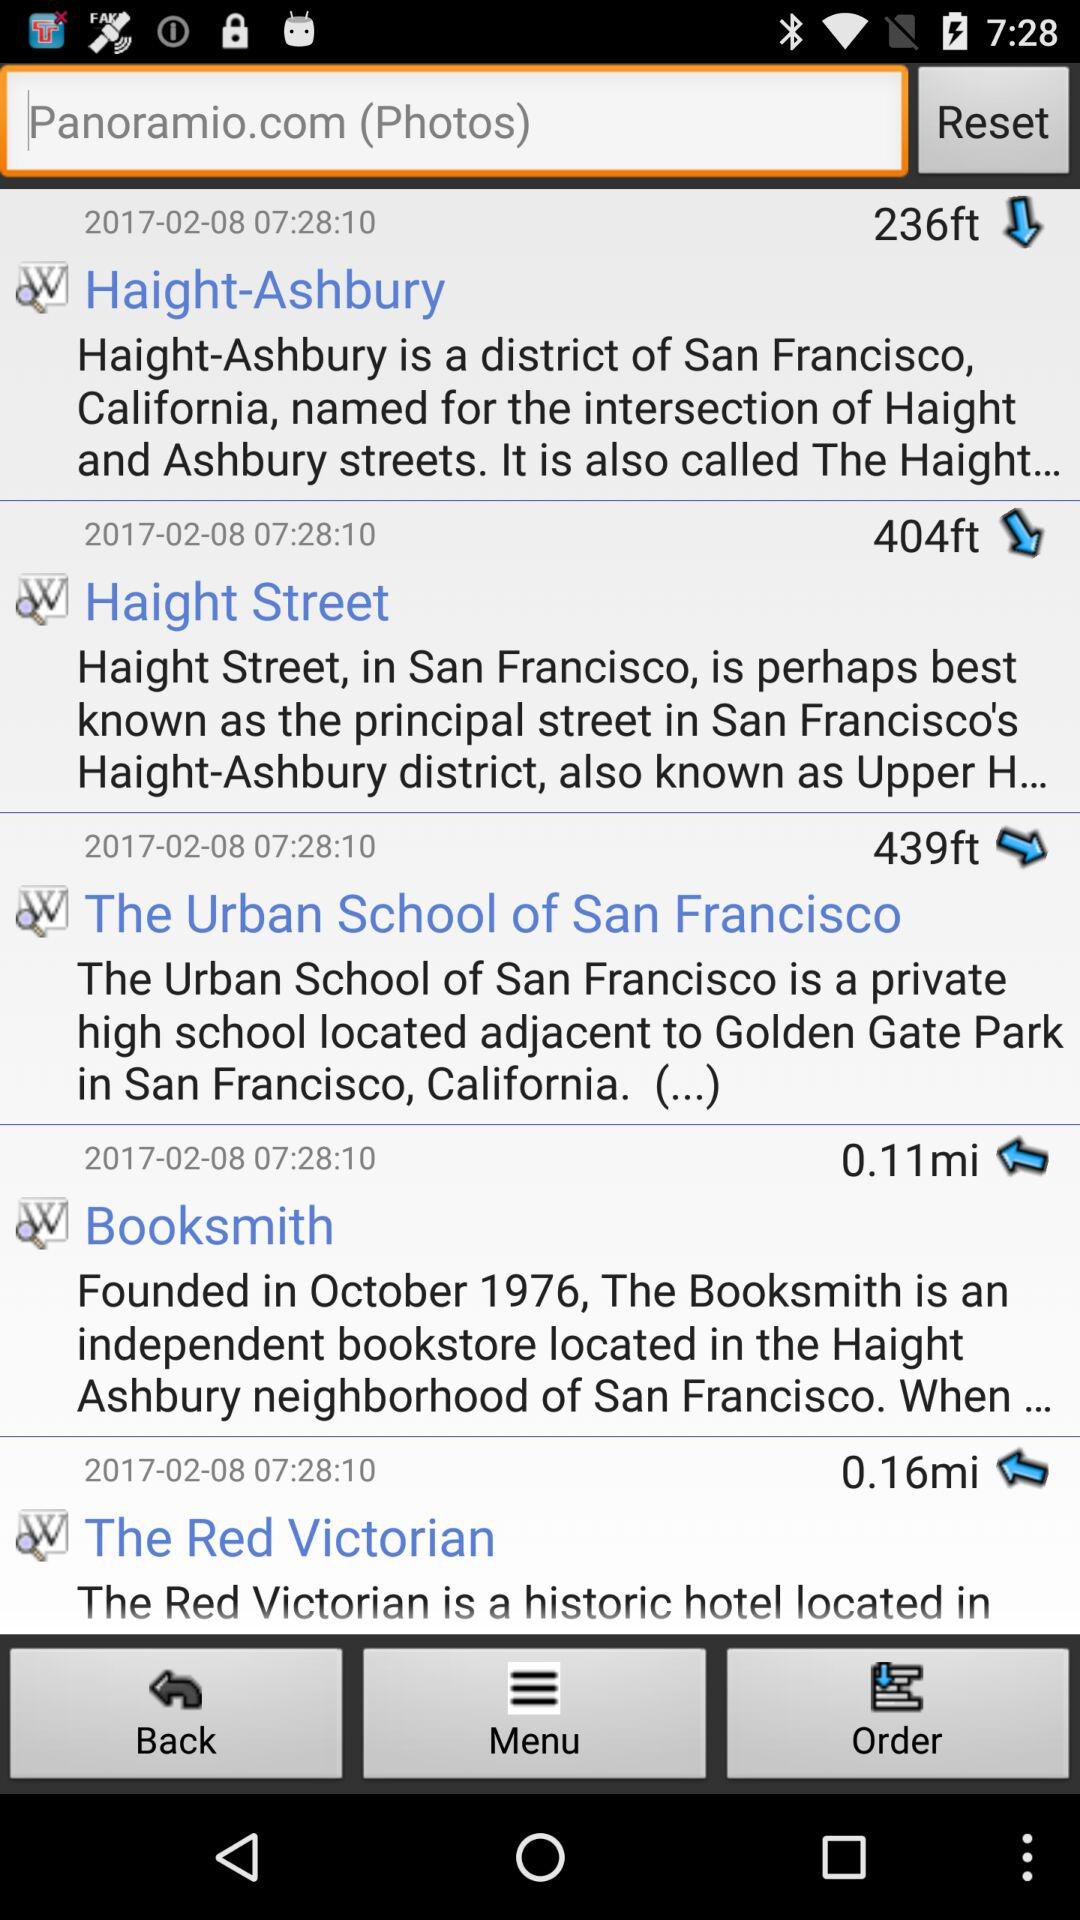Which historical place has a 404-foot altitude? The historical place with 404-foot altitude is Haight Street. 